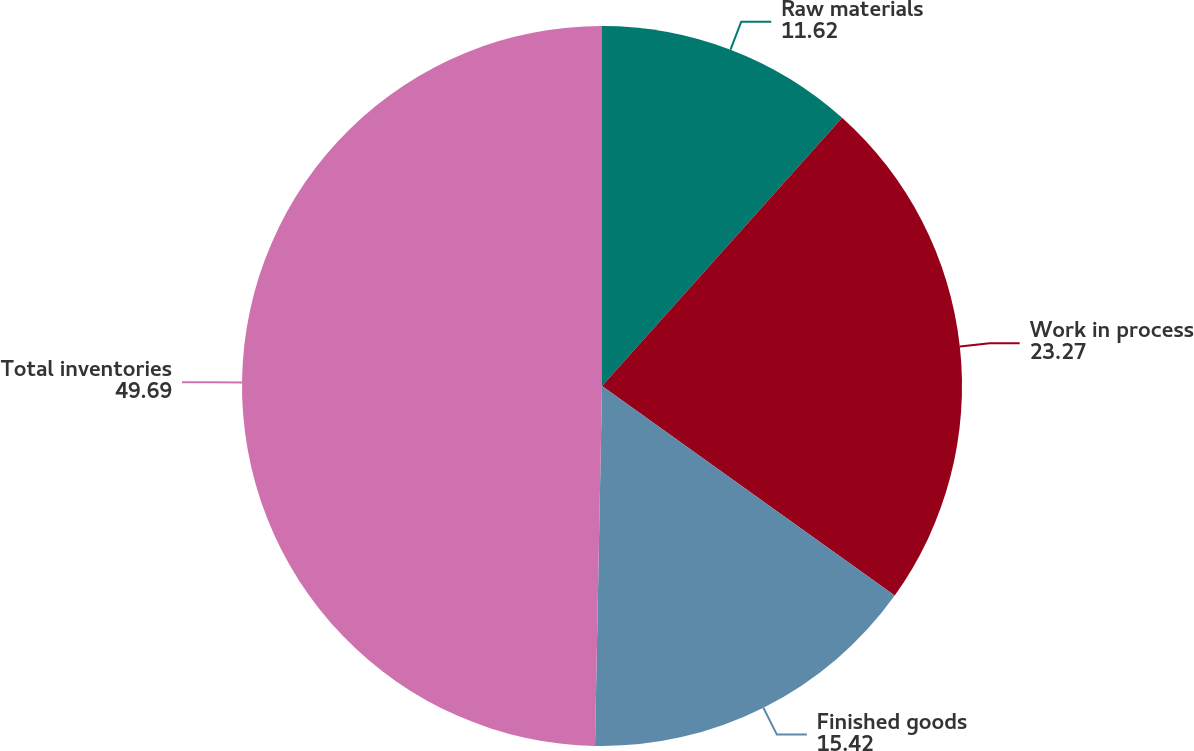<chart> <loc_0><loc_0><loc_500><loc_500><pie_chart><fcel>Raw materials<fcel>Work in process<fcel>Finished goods<fcel>Total inventories<nl><fcel>11.62%<fcel>23.27%<fcel>15.42%<fcel>49.69%<nl></chart> 